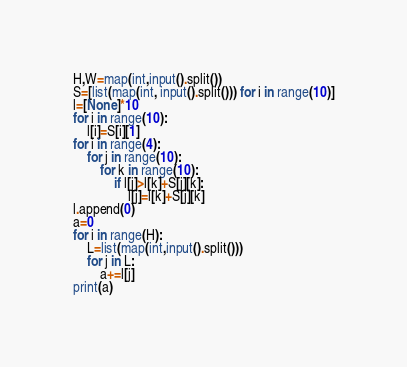<code> <loc_0><loc_0><loc_500><loc_500><_Python_>H,W=map(int,input().split())
S=[list(map(int, input().split())) for i in range(10)]
l=[None]*10
for i in range(10):
    l[i]=S[i][1]
for i in range(4):
    for j in range(10):
        for k in range(10):
            if l[j]>l[k]+S[j][k]:
                l[j]=l[k]+S[j][k]
l.append(0)
a=0
for i in range(H):
    L=list(map(int,input().split()))
    for j in L:
        a+=l[j]
print(a)</code> 